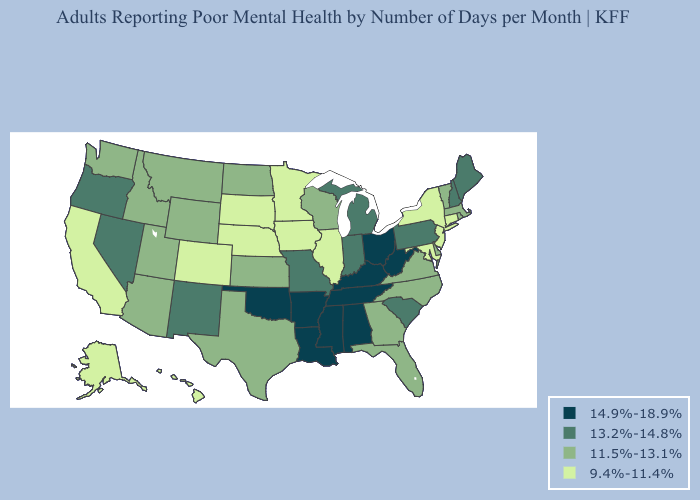Does Alabama have a lower value than Wisconsin?
Answer briefly. No. What is the highest value in states that border Minnesota?
Concise answer only. 11.5%-13.1%. Does Hawaii have the same value as Minnesota?
Concise answer only. Yes. What is the value of Wyoming?
Answer briefly. 11.5%-13.1%. Name the states that have a value in the range 11.5%-13.1%?
Concise answer only. Arizona, Delaware, Florida, Georgia, Idaho, Kansas, Massachusetts, Montana, North Carolina, North Dakota, Rhode Island, Texas, Utah, Vermont, Virginia, Washington, Wisconsin, Wyoming. What is the lowest value in states that border Nebraska?
Short answer required. 9.4%-11.4%. Name the states that have a value in the range 11.5%-13.1%?
Give a very brief answer. Arizona, Delaware, Florida, Georgia, Idaho, Kansas, Massachusetts, Montana, North Carolina, North Dakota, Rhode Island, Texas, Utah, Vermont, Virginia, Washington, Wisconsin, Wyoming. What is the highest value in the MidWest ?
Quick response, please. 14.9%-18.9%. What is the highest value in the South ?
Answer briefly. 14.9%-18.9%. What is the value of California?
Concise answer only. 9.4%-11.4%. Name the states that have a value in the range 9.4%-11.4%?
Concise answer only. Alaska, California, Colorado, Connecticut, Hawaii, Illinois, Iowa, Maryland, Minnesota, Nebraska, New Jersey, New York, South Dakota. Does the first symbol in the legend represent the smallest category?
Keep it brief. No. Among the states that border Colorado , does New Mexico have the lowest value?
Answer briefly. No. Name the states that have a value in the range 11.5%-13.1%?
Quick response, please. Arizona, Delaware, Florida, Georgia, Idaho, Kansas, Massachusetts, Montana, North Carolina, North Dakota, Rhode Island, Texas, Utah, Vermont, Virginia, Washington, Wisconsin, Wyoming. Among the states that border North Carolina , does South Carolina have the highest value?
Give a very brief answer. No. 